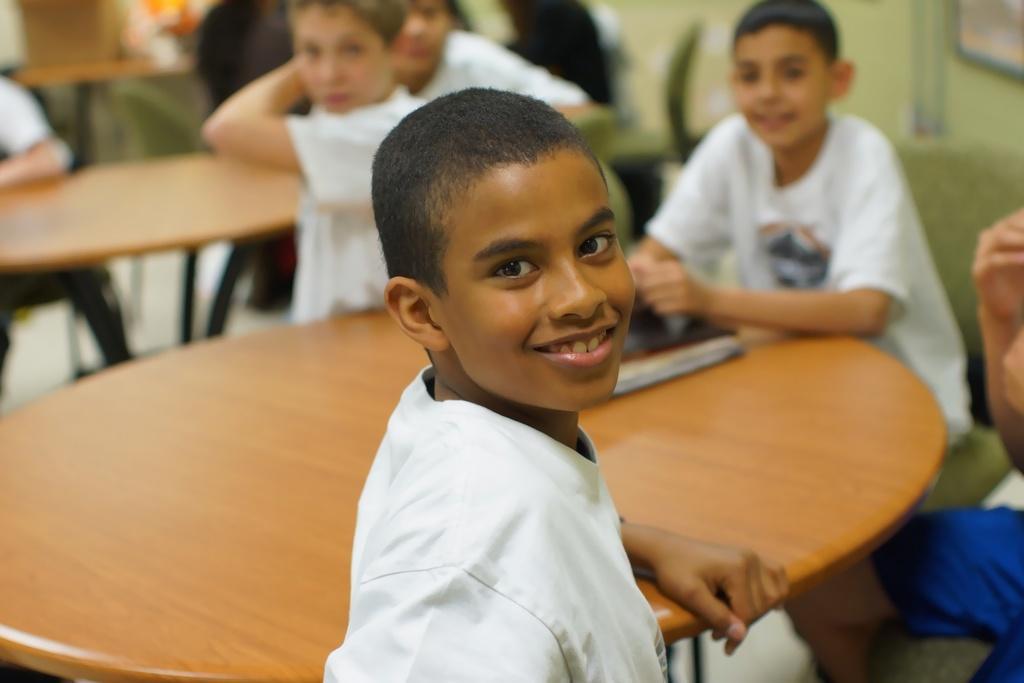Please provide a concise description of this image. In this image I see a boy who is smiling and is in front of a table. In the background I see lot of boys and there is another table over here. 